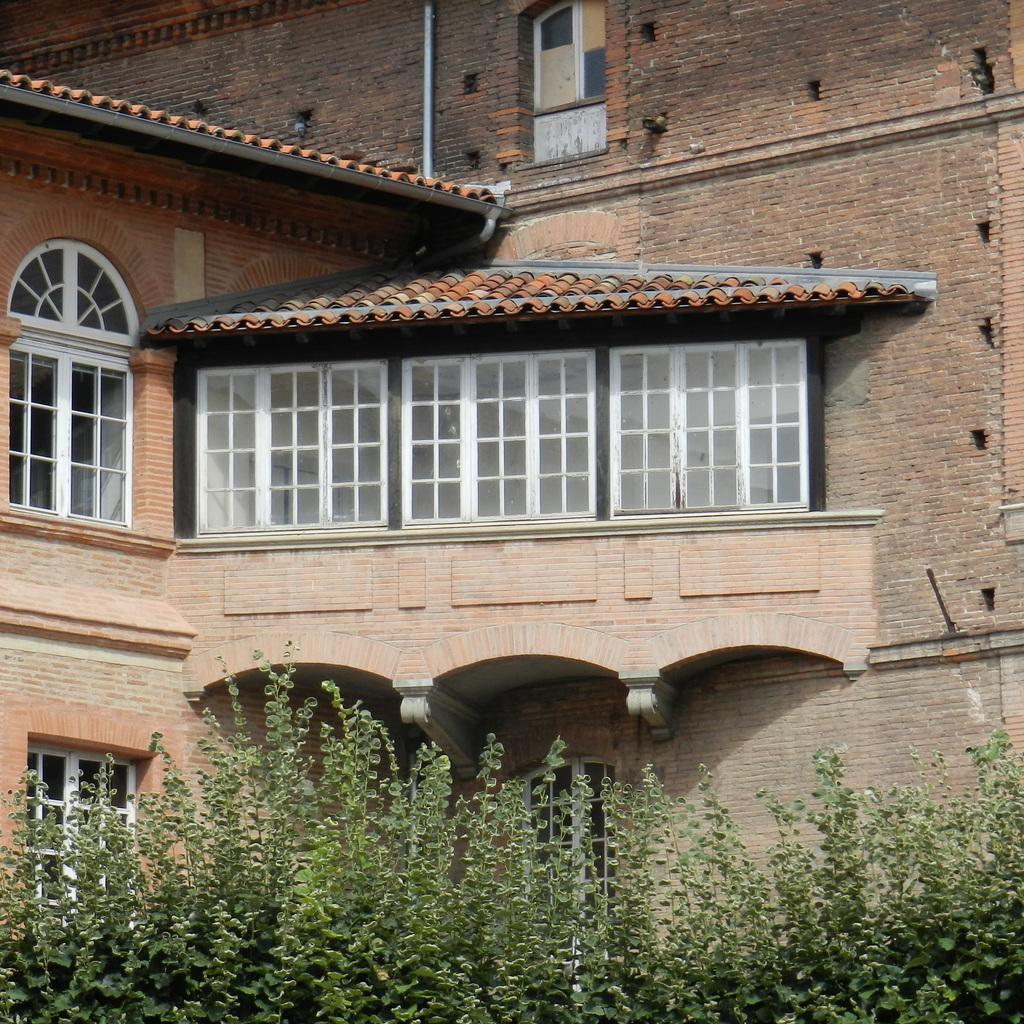What type of structure is present in the image? There is a building in the image. What other elements can be seen in the image besides the building? There are plants and windows visible in the image. Can you describe the pipe that is attached to the wall in the image? There is a white color pipe attached to the wall in the image. What advice does the person's dad give them in the image? There is no person or their dad present in the image, so it is not possible to answer that question. 